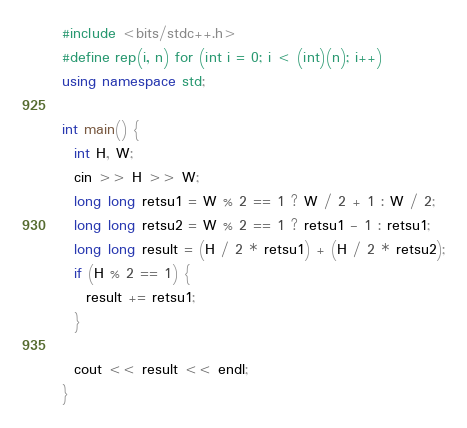Convert code to text. <code><loc_0><loc_0><loc_500><loc_500><_C++_>#include <bits/stdc++.h>
#define rep(i, n) for (int i = 0; i < (int)(n); i++)
using namespace std;

int main() {
  int H, W;
  cin >> H >> W;
  long long retsu1 = W % 2 == 1 ? W / 2 + 1 : W / 2;
  long long retsu2 = W % 2 == 1 ? retsu1 - 1 : retsu1;
  long long result = (H / 2 * retsu1) + (H / 2 * retsu2);
  if (H % 2 == 1) {
    result += retsu1;
  }
  
  cout << result << endl;
}

</code> 